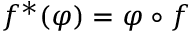Convert formula to latex. <formula><loc_0><loc_0><loc_500><loc_500>f ^ { * } ( \varphi ) = \varphi \circ f</formula> 